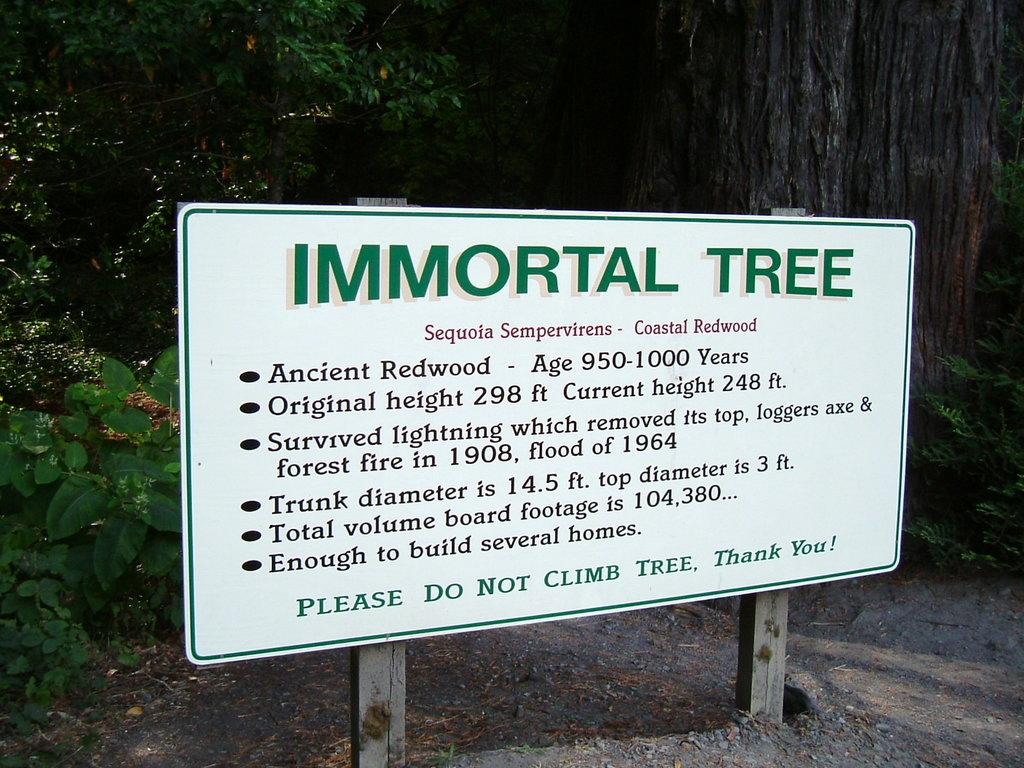What is located in the center of the image? There is a board in the center of the image. What can be seen in the background of the image? There are trees and plants in the background of the image. What type of chain can be seen hanging from the board in the image? There is no chain present hanging from the board in the image. 